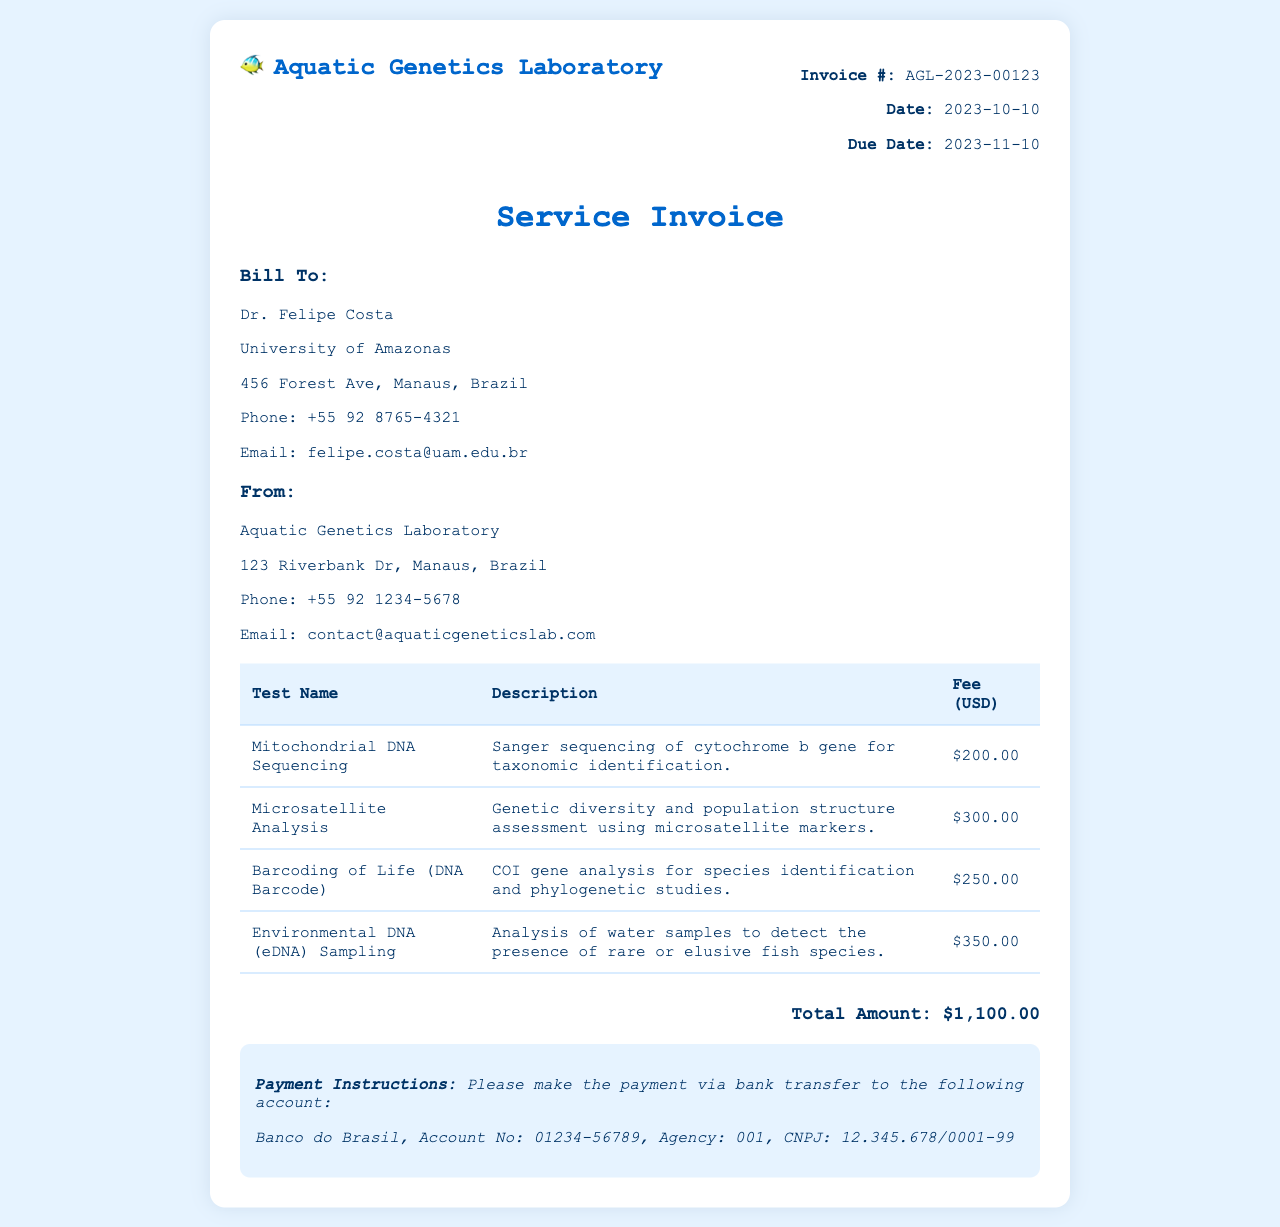What is the invoice number? The invoice number is clearly specified in the document as a unique identifier for this transaction.
Answer: AGL-2023-00123 What is the total amount due? The total amount due is prominently displayed at the end of the invoice, summarizing the cost of services rendered.
Answer: $1,100.00 Who is the client? The client's name is provided in the 'Bill To' section, indicating the recipient of the services.
Answer: Dr. Felipe Costa What type of test is 'Environmental DNA (eDNA) Sampling'? The document describes each test in detail, including its purpose, which provides insight into the nature of the service performed.
Answer: Analysis of water samples to detect the presence of rare or elusive fish species When is the payment due? The due date is explicitly mentioned in the document, outlining when the payment must be made to avoid penalties.
Answer: 2023-11-10 What is the fee for Microsatellite Analysis? The fee for each specific service is listed alongside its description in the invoice for transparency.
Answer: $300.00 Which laboratory issued the invoice? The issuing laboratory's name and contact information is included at the beginning of the document.
Answer: Aquatic Genetics Laboratory What does the 'Payment Instructions' section indicate? This section provides essential information on how to make the payment, including banking details.
Answer: Bank transfer to Banco do Brasil 